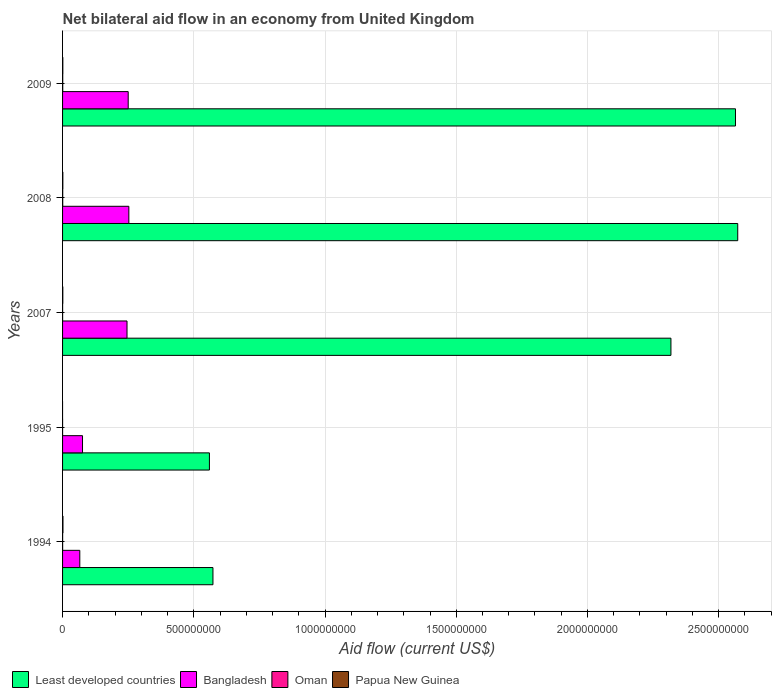How many different coloured bars are there?
Provide a short and direct response. 4. Are the number of bars per tick equal to the number of legend labels?
Provide a short and direct response. No. Are the number of bars on each tick of the Y-axis equal?
Provide a succinct answer. No. How many bars are there on the 1st tick from the top?
Your answer should be very brief. 4. How many bars are there on the 1st tick from the bottom?
Ensure brevity in your answer.  4. What is the label of the 5th group of bars from the top?
Provide a short and direct response. 1994. In how many cases, is the number of bars for a given year not equal to the number of legend labels?
Your answer should be very brief. 1. What is the net bilateral aid flow in Papua New Guinea in 1994?
Offer a very short reply. 1.51e+06. Across all years, what is the maximum net bilateral aid flow in Oman?
Keep it short and to the point. 6.40e+05. Across all years, what is the minimum net bilateral aid flow in Oman?
Your answer should be very brief. 4.00e+04. In which year was the net bilateral aid flow in Least developed countries maximum?
Your answer should be compact. 2008. What is the total net bilateral aid flow in Oman in the graph?
Keep it short and to the point. 1.62e+06. What is the difference between the net bilateral aid flow in Least developed countries in 2007 and that in 2009?
Ensure brevity in your answer.  -2.46e+08. What is the difference between the net bilateral aid flow in Bangladesh in 2009 and the net bilateral aid flow in Least developed countries in 2007?
Make the answer very short. -2.07e+09. What is the average net bilateral aid flow in Bangladesh per year?
Offer a very short reply. 1.78e+08. In the year 1995, what is the difference between the net bilateral aid flow in Oman and net bilateral aid flow in Bangladesh?
Give a very brief answer. -7.60e+07. What is the ratio of the net bilateral aid flow in Bangladesh in 1995 to that in 2007?
Ensure brevity in your answer.  0.31. Is it the case that in every year, the sum of the net bilateral aid flow in Papua New Guinea and net bilateral aid flow in Oman is greater than the sum of net bilateral aid flow in Least developed countries and net bilateral aid flow in Bangladesh?
Keep it short and to the point. No. Is it the case that in every year, the sum of the net bilateral aid flow in Oman and net bilateral aid flow in Bangladesh is greater than the net bilateral aid flow in Least developed countries?
Your answer should be very brief. No. How many bars are there?
Offer a very short reply. 19. Are all the bars in the graph horizontal?
Ensure brevity in your answer.  Yes. How many years are there in the graph?
Your response must be concise. 5. What is the difference between two consecutive major ticks on the X-axis?
Make the answer very short. 5.00e+08. Are the values on the major ticks of X-axis written in scientific E-notation?
Make the answer very short. No. Does the graph contain any zero values?
Make the answer very short. Yes. Does the graph contain grids?
Provide a succinct answer. Yes. Where does the legend appear in the graph?
Give a very brief answer. Bottom left. What is the title of the graph?
Your answer should be compact. Net bilateral aid flow in an economy from United Kingdom. Does "Suriname" appear as one of the legend labels in the graph?
Give a very brief answer. No. What is the Aid flow (current US$) of Least developed countries in 1994?
Your answer should be very brief. 5.73e+08. What is the Aid flow (current US$) in Bangladesh in 1994?
Provide a succinct answer. 6.57e+07. What is the Aid flow (current US$) in Oman in 1994?
Ensure brevity in your answer.  2.10e+05. What is the Aid flow (current US$) of Papua New Guinea in 1994?
Your answer should be compact. 1.51e+06. What is the Aid flow (current US$) of Least developed countries in 1995?
Keep it short and to the point. 5.60e+08. What is the Aid flow (current US$) of Bangladesh in 1995?
Make the answer very short. 7.60e+07. What is the Aid flow (current US$) in Oman in 1995?
Give a very brief answer. 4.00e+04. What is the Aid flow (current US$) in Papua New Guinea in 1995?
Offer a very short reply. 0. What is the Aid flow (current US$) of Least developed countries in 2007?
Your answer should be very brief. 2.32e+09. What is the Aid flow (current US$) in Bangladesh in 2007?
Your answer should be compact. 2.46e+08. What is the Aid flow (current US$) in Papua New Guinea in 2007?
Your answer should be very brief. 9.60e+05. What is the Aid flow (current US$) in Least developed countries in 2008?
Provide a short and direct response. 2.57e+09. What is the Aid flow (current US$) of Bangladesh in 2008?
Make the answer very short. 2.53e+08. What is the Aid flow (current US$) of Oman in 2008?
Your answer should be compact. 5.60e+05. What is the Aid flow (current US$) of Papua New Guinea in 2008?
Offer a very short reply. 1.07e+06. What is the Aid flow (current US$) of Least developed countries in 2009?
Keep it short and to the point. 2.56e+09. What is the Aid flow (current US$) in Bangladesh in 2009?
Ensure brevity in your answer.  2.50e+08. What is the Aid flow (current US$) in Oman in 2009?
Your response must be concise. 6.40e+05. What is the Aid flow (current US$) in Papua New Guinea in 2009?
Your response must be concise. 9.80e+05. Across all years, what is the maximum Aid flow (current US$) of Least developed countries?
Provide a short and direct response. 2.57e+09. Across all years, what is the maximum Aid flow (current US$) of Bangladesh?
Give a very brief answer. 2.53e+08. Across all years, what is the maximum Aid flow (current US$) of Oman?
Provide a succinct answer. 6.40e+05. Across all years, what is the maximum Aid flow (current US$) in Papua New Guinea?
Your answer should be very brief. 1.51e+06. Across all years, what is the minimum Aid flow (current US$) of Least developed countries?
Provide a succinct answer. 5.60e+08. Across all years, what is the minimum Aid flow (current US$) in Bangladesh?
Keep it short and to the point. 6.57e+07. Across all years, what is the minimum Aid flow (current US$) in Oman?
Your response must be concise. 4.00e+04. What is the total Aid flow (current US$) of Least developed countries in the graph?
Your response must be concise. 8.59e+09. What is the total Aid flow (current US$) in Bangladesh in the graph?
Provide a short and direct response. 8.90e+08. What is the total Aid flow (current US$) of Oman in the graph?
Make the answer very short. 1.62e+06. What is the total Aid flow (current US$) of Papua New Guinea in the graph?
Give a very brief answer. 4.52e+06. What is the difference between the Aid flow (current US$) in Least developed countries in 1994 and that in 1995?
Your answer should be very brief. 1.34e+07. What is the difference between the Aid flow (current US$) of Bangladesh in 1994 and that in 1995?
Provide a succinct answer. -1.03e+07. What is the difference between the Aid flow (current US$) in Oman in 1994 and that in 1995?
Ensure brevity in your answer.  1.70e+05. What is the difference between the Aid flow (current US$) in Least developed countries in 1994 and that in 2007?
Your answer should be very brief. -1.75e+09. What is the difference between the Aid flow (current US$) of Bangladesh in 1994 and that in 2007?
Make the answer very short. -1.80e+08. What is the difference between the Aid flow (current US$) of Papua New Guinea in 1994 and that in 2007?
Give a very brief answer. 5.50e+05. What is the difference between the Aid flow (current US$) in Least developed countries in 1994 and that in 2008?
Keep it short and to the point. -2.00e+09. What is the difference between the Aid flow (current US$) in Bangladesh in 1994 and that in 2008?
Give a very brief answer. -1.87e+08. What is the difference between the Aid flow (current US$) in Oman in 1994 and that in 2008?
Your answer should be compact. -3.50e+05. What is the difference between the Aid flow (current US$) of Least developed countries in 1994 and that in 2009?
Make the answer very short. -1.99e+09. What is the difference between the Aid flow (current US$) of Bangladesh in 1994 and that in 2009?
Provide a short and direct response. -1.84e+08. What is the difference between the Aid flow (current US$) of Oman in 1994 and that in 2009?
Make the answer very short. -4.30e+05. What is the difference between the Aid flow (current US$) of Papua New Guinea in 1994 and that in 2009?
Make the answer very short. 5.30e+05. What is the difference between the Aid flow (current US$) of Least developed countries in 1995 and that in 2007?
Provide a short and direct response. -1.76e+09. What is the difference between the Aid flow (current US$) of Bangladesh in 1995 and that in 2007?
Your answer should be compact. -1.70e+08. What is the difference between the Aid flow (current US$) in Oman in 1995 and that in 2007?
Give a very brief answer. -1.30e+05. What is the difference between the Aid flow (current US$) of Least developed countries in 1995 and that in 2008?
Your answer should be very brief. -2.01e+09. What is the difference between the Aid flow (current US$) in Bangladesh in 1995 and that in 2008?
Your answer should be compact. -1.77e+08. What is the difference between the Aid flow (current US$) of Oman in 1995 and that in 2008?
Provide a short and direct response. -5.20e+05. What is the difference between the Aid flow (current US$) of Least developed countries in 1995 and that in 2009?
Your answer should be very brief. -2.00e+09. What is the difference between the Aid flow (current US$) of Bangladesh in 1995 and that in 2009?
Offer a terse response. -1.74e+08. What is the difference between the Aid flow (current US$) of Oman in 1995 and that in 2009?
Make the answer very short. -6.00e+05. What is the difference between the Aid flow (current US$) of Least developed countries in 2007 and that in 2008?
Keep it short and to the point. -2.55e+08. What is the difference between the Aid flow (current US$) in Bangladesh in 2007 and that in 2008?
Your answer should be compact. -6.96e+06. What is the difference between the Aid flow (current US$) of Oman in 2007 and that in 2008?
Provide a succinct answer. -3.90e+05. What is the difference between the Aid flow (current US$) of Papua New Guinea in 2007 and that in 2008?
Offer a terse response. -1.10e+05. What is the difference between the Aid flow (current US$) of Least developed countries in 2007 and that in 2009?
Provide a succinct answer. -2.46e+08. What is the difference between the Aid flow (current US$) of Bangladesh in 2007 and that in 2009?
Ensure brevity in your answer.  -4.51e+06. What is the difference between the Aid flow (current US$) in Oman in 2007 and that in 2009?
Make the answer very short. -4.70e+05. What is the difference between the Aid flow (current US$) in Papua New Guinea in 2007 and that in 2009?
Give a very brief answer. -2.00e+04. What is the difference between the Aid flow (current US$) of Least developed countries in 2008 and that in 2009?
Your answer should be compact. 8.55e+06. What is the difference between the Aid flow (current US$) of Bangladesh in 2008 and that in 2009?
Provide a succinct answer. 2.45e+06. What is the difference between the Aid flow (current US$) in Oman in 2008 and that in 2009?
Give a very brief answer. -8.00e+04. What is the difference between the Aid flow (current US$) in Papua New Guinea in 2008 and that in 2009?
Provide a succinct answer. 9.00e+04. What is the difference between the Aid flow (current US$) of Least developed countries in 1994 and the Aid flow (current US$) of Bangladesh in 1995?
Your response must be concise. 4.97e+08. What is the difference between the Aid flow (current US$) of Least developed countries in 1994 and the Aid flow (current US$) of Oman in 1995?
Make the answer very short. 5.73e+08. What is the difference between the Aid flow (current US$) of Bangladesh in 1994 and the Aid flow (current US$) of Oman in 1995?
Your answer should be very brief. 6.56e+07. What is the difference between the Aid flow (current US$) in Least developed countries in 1994 and the Aid flow (current US$) in Bangladesh in 2007?
Keep it short and to the point. 3.27e+08. What is the difference between the Aid flow (current US$) of Least developed countries in 1994 and the Aid flow (current US$) of Oman in 2007?
Your answer should be compact. 5.73e+08. What is the difference between the Aid flow (current US$) in Least developed countries in 1994 and the Aid flow (current US$) in Papua New Guinea in 2007?
Keep it short and to the point. 5.72e+08. What is the difference between the Aid flow (current US$) of Bangladesh in 1994 and the Aid flow (current US$) of Oman in 2007?
Your response must be concise. 6.55e+07. What is the difference between the Aid flow (current US$) of Bangladesh in 1994 and the Aid flow (current US$) of Papua New Guinea in 2007?
Ensure brevity in your answer.  6.47e+07. What is the difference between the Aid flow (current US$) of Oman in 1994 and the Aid flow (current US$) of Papua New Guinea in 2007?
Offer a terse response. -7.50e+05. What is the difference between the Aid flow (current US$) in Least developed countries in 1994 and the Aid flow (current US$) in Bangladesh in 2008?
Your answer should be compact. 3.20e+08. What is the difference between the Aid flow (current US$) of Least developed countries in 1994 and the Aid flow (current US$) of Oman in 2008?
Your answer should be compact. 5.72e+08. What is the difference between the Aid flow (current US$) in Least developed countries in 1994 and the Aid flow (current US$) in Papua New Guinea in 2008?
Your response must be concise. 5.72e+08. What is the difference between the Aid flow (current US$) of Bangladesh in 1994 and the Aid flow (current US$) of Oman in 2008?
Make the answer very short. 6.51e+07. What is the difference between the Aid flow (current US$) in Bangladesh in 1994 and the Aid flow (current US$) in Papua New Guinea in 2008?
Make the answer very short. 6.46e+07. What is the difference between the Aid flow (current US$) in Oman in 1994 and the Aid flow (current US$) in Papua New Guinea in 2008?
Provide a short and direct response. -8.60e+05. What is the difference between the Aid flow (current US$) in Least developed countries in 1994 and the Aid flow (current US$) in Bangladesh in 2009?
Your answer should be very brief. 3.23e+08. What is the difference between the Aid flow (current US$) of Least developed countries in 1994 and the Aid flow (current US$) of Oman in 2009?
Offer a very short reply. 5.72e+08. What is the difference between the Aid flow (current US$) in Least developed countries in 1994 and the Aid flow (current US$) in Papua New Guinea in 2009?
Your answer should be compact. 5.72e+08. What is the difference between the Aid flow (current US$) of Bangladesh in 1994 and the Aid flow (current US$) of Oman in 2009?
Offer a very short reply. 6.50e+07. What is the difference between the Aid flow (current US$) in Bangladesh in 1994 and the Aid flow (current US$) in Papua New Guinea in 2009?
Offer a very short reply. 6.47e+07. What is the difference between the Aid flow (current US$) in Oman in 1994 and the Aid flow (current US$) in Papua New Guinea in 2009?
Offer a terse response. -7.70e+05. What is the difference between the Aid flow (current US$) in Least developed countries in 1995 and the Aid flow (current US$) in Bangladesh in 2007?
Provide a succinct answer. 3.14e+08. What is the difference between the Aid flow (current US$) in Least developed countries in 1995 and the Aid flow (current US$) in Oman in 2007?
Your answer should be very brief. 5.59e+08. What is the difference between the Aid flow (current US$) of Least developed countries in 1995 and the Aid flow (current US$) of Papua New Guinea in 2007?
Offer a very short reply. 5.59e+08. What is the difference between the Aid flow (current US$) of Bangladesh in 1995 and the Aid flow (current US$) of Oman in 2007?
Provide a succinct answer. 7.58e+07. What is the difference between the Aid flow (current US$) in Bangladesh in 1995 and the Aid flow (current US$) in Papua New Guinea in 2007?
Your answer should be compact. 7.50e+07. What is the difference between the Aid flow (current US$) of Oman in 1995 and the Aid flow (current US$) of Papua New Guinea in 2007?
Ensure brevity in your answer.  -9.20e+05. What is the difference between the Aid flow (current US$) of Least developed countries in 1995 and the Aid flow (current US$) of Bangladesh in 2008?
Keep it short and to the point. 3.07e+08. What is the difference between the Aid flow (current US$) of Least developed countries in 1995 and the Aid flow (current US$) of Oman in 2008?
Ensure brevity in your answer.  5.59e+08. What is the difference between the Aid flow (current US$) in Least developed countries in 1995 and the Aid flow (current US$) in Papua New Guinea in 2008?
Provide a succinct answer. 5.59e+08. What is the difference between the Aid flow (current US$) in Bangladesh in 1995 and the Aid flow (current US$) in Oman in 2008?
Offer a very short reply. 7.54e+07. What is the difference between the Aid flow (current US$) of Bangladesh in 1995 and the Aid flow (current US$) of Papua New Guinea in 2008?
Offer a very short reply. 7.49e+07. What is the difference between the Aid flow (current US$) of Oman in 1995 and the Aid flow (current US$) of Papua New Guinea in 2008?
Offer a terse response. -1.03e+06. What is the difference between the Aid flow (current US$) in Least developed countries in 1995 and the Aid flow (current US$) in Bangladesh in 2009?
Keep it short and to the point. 3.10e+08. What is the difference between the Aid flow (current US$) in Least developed countries in 1995 and the Aid flow (current US$) in Oman in 2009?
Your answer should be compact. 5.59e+08. What is the difference between the Aid flow (current US$) in Least developed countries in 1995 and the Aid flow (current US$) in Papua New Guinea in 2009?
Give a very brief answer. 5.59e+08. What is the difference between the Aid flow (current US$) of Bangladesh in 1995 and the Aid flow (current US$) of Oman in 2009?
Ensure brevity in your answer.  7.54e+07. What is the difference between the Aid flow (current US$) in Bangladesh in 1995 and the Aid flow (current US$) in Papua New Guinea in 2009?
Ensure brevity in your answer.  7.50e+07. What is the difference between the Aid flow (current US$) in Oman in 1995 and the Aid flow (current US$) in Papua New Guinea in 2009?
Make the answer very short. -9.40e+05. What is the difference between the Aid flow (current US$) of Least developed countries in 2007 and the Aid flow (current US$) of Bangladesh in 2008?
Offer a very short reply. 2.07e+09. What is the difference between the Aid flow (current US$) in Least developed countries in 2007 and the Aid flow (current US$) in Oman in 2008?
Provide a succinct answer. 2.32e+09. What is the difference between the Aid flow (current US$) of Least developed countries in 2007 and the Aid flow (current US$) of Papua New Guinea in 2008?
Offer a terse response. 2.32e+09. What is the difference between the Aid flow (current US$) in Bangladesh in 2007 and the Aid flow (current US$) in Oman in 2008?
Make the answer very short. 2.45e+08. What is the difference between the Aid flow (current US$) in Bangladesh in 2007 and the Aid flow (current US$) in Papua New Guinea in 2008?
Your answer should be very brief. 2.44e+08. What is the difference between the Aid flow (current US$) in Oman in 2007 and the Aid flow (current US$) in Papua New Guinea in 2008?
Your answer should be compact. -9.00e+05. What is the difference between the Aid flow (current US$) of Least developed countries in 2007 and the Aid flow (current US$) of Bangladesh in 2009?
Provide a succinct answer. 2.07e+09. What is the difference between the Aid flow (current US$) in Least developed countries in 2007 and the Aid flow (current US$) in Oman in 2009?
Offer a very short reply. 2.32e+09. What is the difference between the Aid flow (current US$) in Least developed countries in 2007 and the Aid flow (current US$) in Papua New Guinea in 2009?
Your answer should be compact. 2.32e+09. What is the difference between the Aid flow (current US$) of Bangladesh in 2007 and the Aid flow (current US$) of Oman in 2009?
Make the answer very short. 2.45e+08. What is the difference between the Aid flow (current US$) of Bangladesh in 2007 and the Aid flow (current US$) of Papua New Guinea in 2009?
Provide a succinct answer. 2.45e+08. What is the difference between the Aid flow (current US$) in Oman in 2007 and the Aid flow (current US$) in Papua New Guinea in 2009?
Offer a very short reply. -8.10e+05. What is the difference between the Aid flow (current US$) of Least developed countries in 2008 and the Aid flow (current US$) of Bangladesh in 2009?
Make the answer very short. 2.32e+09. What is the difference between the Aid flow (current US$) in Least developed countries in 2008 and the Aid flow (current US$) in Oman in 2009?
Your answer should be compact. 2.57e+09. What is the difference between the Aid flow (current US$) of Least developed countries in 2008 and the Aid flow (current US$) of Papua New Guinea in 2009?
Your answer should be very brief. 2.57e+09. What is the difference between the Aid flow (current US$) in Bangladesh in 2008 and the Aid flow (current US$) in Oman in 2009?
Provide a short and direct response. 2.52e+08. What is the difference between the Aid flow (current US$) of Bangladesh in 2008 and the Aid flow (current US$) of Papua New Guinea in 2009?
Keep it short and to the point. 2.52e+08. What is the difference between the Aid flow (current US$) in Oman in 2008 and the Aid flow (current US$) in Papua New Guinea in 2009?
Your response must be concise. -4.20e+05. What is the average Aid flow (current US$) of Least developed countries per year?
Your answer should be very brief. 1.72e+09. What is the average Aid flow (current US$) of Bangladesh per year?
Offer a very short reply. 1.78e+08. What is the average Aid flow (current US$) in Oman per year?
Your answer should be compact. 3.24e+05. What is the average Aid flow (current US$) in Papua New Guinea per year?
Provide a short and direct response. 9.04e+05. In the year 1994, what is the difference between the Aid flow (current US$) of Least developed countries and Aid flow (current US$) of Bangladesh?
Your answer should be very brief. 5.07e+08. In the year 1994, what is the difference between the Aid flow (current US$) in Least developed countries and Aid flow (current US$) in Oman?
Provide a short and direct response. 5.73e+08. In the year 1994, what is the difference between the Aid flow (current US$) in Least developed countries and Aid flow (current US$) in Papua New Guinea?
Offer a very short reply. 5.71e+08. In the year 1994, what is the difference between the Aid flow (current US$) in Bangladesh and Aid flow (current US$) in Oman?
Make the answer very short. 6.55e+07. In the year 1994, what is the difference between the Aid flow (current US$) in Bangladesh and Aid flow (current US$) in Papua New Guinea?
Your answer should be very brief. 6.42e+07. In the year 1994, what is the difference between the Aid flow (current US$) in Oman and Aid flow (current US$) in Papua New Guinea?
Provide a short and direct response. -1.30e+06. In the year 1995, what is the difference between the Aid flow (current US$) of Least developed countries and Aid flow (current US$) of Bangladesh?
Offer a terse response. 4.84e+08. In the year 1995, what is the difference between the Aid flow (current US$) in Least developed countries and Aid flow (current US$) in Oman?
Your answer should be very brief. 5.60e+08. In the year 1995, what is the difference between the Aid flow (current US$) of Bangladesh and Aid flow (current US$) of Oman?
Offer a very short reply. 7.60e+07. In the year 2007, what is the difference between the Aid flow (current US$) in Least developed countries and Aid flow (current US$) in Bangladesh?
Give a very brief answer. 2.07e+09. In the year 2007, what is the difference between the Aid flow (current US$) of Least developed countries and Aid flow (current US$) of Oman?
Your answer should be very brief. 2.32e+09. In the year 2007, what is the difference between the Aid flow (current US$) in Least developed countries and Aid flow (current US$) in Papua New Guinea?
Offer a terse response. 2.32e+09. In the year 2007, what is the difference between the Aid flow (current US$) in Bangladesh and Aid flow (current US$) in Oman?
Provide a succinct answer. 2.45e+08. In the year 2007, what is the difference between the Aid flow (current US$) in Bangladesh and Aid flow (current US$) in Papua New Guinea?
Give a very brief answer. 2.45e+08. In the year 2007, what is the difference between the Aid flow (current US$) in Oman and Aid flow (current US$) in Papua New Guinea?
Offer a terse response. -7.90e+05. In the year 2008, what is the difference between the Aid flow (current US$) of Least developed countries and Aid flow (current US$) of Bangladesh?
Make the answer very short. 2.32e+09. In the year 2008, what is the difference between the Aid flow (current US$) in Least developed countries and Aid flow (current US$) in Oman?
Keep it short and to the point. 2.57e+09. In the year 2008, what is the difference between the Aid flow (current US$) of Least developed countries and Aid flow (current US$) of Papua New Guinea?
Your answer should be compact. 2.57e+09. In the year 2008, what is the difference between the Aid flow (current US$) of Bangladesh and Aid flow (current US$) of Oman?
Ensure brevity in your answer.  2.52e+08. In the year 2008, what is the difference between the Aid flow (current US$) in Bangladesh and Aid flow (current US$) in Papua New Guinea?
Your response must be concise. 2.51e+08. In the year 2008, what is the difference between the Aid flow (current US$) in Oman and Aid flow (current US$) in Papua New Guinea?
Make the answer very short. -5.10e+05. In the year 2009, what is the difference between the Aid flow (current US$) of Least developed countries and Aid flow (current US$) of Bangladesh?
Your response must be concise. 2.31e+09. In the year 2009, what is the difference between the Aid flow (current US$) in Least developed countries and Aid flow (current US$) in Oman?
Keep it short and to the point. 2.56e+09. In the year 2009, what is the difference between the Aid flow (current US$) in Least developed countries and Aid flow (current US$) in Papua New Guinea?
Provide a short and direct response. 2.56e+09. In the year 2009, what is the difference between the Aid flow (current US$) in Bangladesh and Aid flow (current US$) in Oman?
Provide a succinct answer. 2.49e+08. In the year 2009, what is the difference between the Aid flow (current US$) in Bangladesh and Aid flow (current US$) in Papua New Guinea?
Your answer should be compact. 2.49e+08. What is the ratio of the Aid flow (current US$) of Least developed countries in 1994 to that in 1995?
Keep it short and to the point. 1.02. What is the ratio of the Aid flow (current US$) in Bangladesh in 1994 to that in 1995?
Your answer should be very brief. 0.86. What is the ratio of the Aid flow (current US$) of Oman in 1994 to that in 1995?
Ensure brevity in your answer.  5.25. What is the ratio of the Aid flow (current US$) of Least developed countries in 1994 to that in 2007?
Offer a very short reply. 0.25. What is the ratio of the Aid flow (current US$) of Bangladesh in 1994 to that in 2007?
Keep it short and to the point. 0.27. What is the ratio of the Aid flow (current US$) in Oman in 1994 to that in 2007?
Keep it short and to the point. 1.24. What is the ratio of the Aid flow (current US$) in Papua New Guinea in 1994 to that in 2007?
Keep it short and to the point. 1.57. What is the ratio of the Aid flow (current US$) of Least developed countries in 1994 to that in 2008?
Your response must be concise. 0.22. What is the ratio of the Aid flow (current US$) of Bangladesh in 1994 to that in 2008?
Offer a very short reply. 0.26. What is the ratio of the Aid flow (current US$) of Oman in 1994 to that in 2008?
Provide a succinct answer. 0.38. What is the ratio of the Aid flow (current US$) in Papua New Guinea in 1994 to that in 2008?
Offer a very short reply. 1.41. What is the ratio of the Aid flow (current US$) in Least developed countries in 1994 to that in 2009?
Your answer should be very brief. 0.22. What is the ratio of the Aid flow (current US$) in Bangladesh in 1994 to that in 2009?
Provide a short and direct response. 0.26. What is the ratio of the Aid flow (current US$) of Oman in 1994 to that in 2009?
Your answer should be compact. 0.33. What is the ratio of the Aid flow (current US$) in Papua New Guinea in 1994 to that in 2009?
Your answer should be very brief. 1.54. What is the ratio of the Aid flow (current US$) of Least developed countries in 1995 to that in 2007?
Offer a terse response. 0.24. What is the ratio of the Aid flow (current US$) of Bangladesh in 1995 to that in 2007?
Provide a succinct answer. 0.31. What is the ratio of the Aid flow (current US$) in Oman in 1995 to that in 2007?
Make the answer very short. 0.24. What is the ratio of the Aid flow (current US$) of Least developed countries in 1995 to that in 2008?
Offer a terse response. 0.22. What is the ratio of the Aid flow (current US$) of Bangladesh in 1995 to that in 2008?
Offer a very short reply. 0.3. What is the ratio of the Aid flow (current US$) of Oman in 1995 to that in 2008?
Your response must be concise. 0.07. What is the ratio of the Aid flow (current US$) of Least developed countries in 1995 to that in 2009?
Offer a terse response. 0.22. What is the ratio of the Aid flow (current US$) in Bangladesh in 1995 to that in 2009?
Your response must be concise. 0.3. What is the ratio of the Aid flow (current US$) in Oman in 1995 to that in 2009?
Give a very brief answer. 0.06. What is the ratio of the Aid flow (current US$) of Least developed countries in 2007 to that in 2008?
Give a very brief answer. 0.9. What is the ratio of the Aid flow (current US$) in Bangladesh in 2007 to that in 2008?
Make the answer very short. 0.97. What is the ratio of the Aid flow (current US$) of Oman in 2007 to that in 2008?
Provide a succinct answer. 0.3. What is the ratio of the Aid flow (current US$) in Papua New Guinea in 2007 to that in 2008?
Your answer should be compact. 0.9. What is the ratio of the Aid flow (current US$) of Least developed countries in 2007 to that in 2009?
Provide a succinct answer. 0.9. What is the ratio of the Aid flow (current US$) of Bangladesh in 2007 to that in 2009?
Make the answer very short. 0.98. What is the ratio of the Aid flow (current US$) in Oman in 2007 to that in 2009?
Offer a terse response. 0.27. What is the ratio of the Aid flow (current US$) in Papua New Guinea in 2007 to that in 2009?
Provide a short and direct response. 0.98. What is the ratio of the Aid flow (current US$) in Least developed countries in 2008 to that in 2009?
Provide a succinct answer. 1. What is the ratio of the Aid flow (current US$) of Bangladesh in 2008 to that in 2009?
Provide a succinct answer. 1.01. What is the ratio of the Aid flow (current US$) in Oman in 2008 to that in 2009?
Your response must be concise. 0.88. What is the ratio of the Aid flow (current US$) in Papua New Guinea in 2008 to that in 2009?
Give a very brief answer. 1.09. What is the difference between the highest and the second highest Aid flow (current US$) of Least developed countries?
Keep it short and to the point. 8.55e+06. What is the difference between the highest and the second highest Aid flow (current US$) in Bangladesh?
Keep it short and to the point. 2.45e+06. What is the difference between the highest and the second highest Aid flow (current US$) of Papua New Guinea?
Your answer should be compact. 4.40e+05. What is the difference between the highest and the lowest Aid flow (current US$) in Least developed countries?
Ensure brevity in your answer.  2.01e+09. What is the difference between the highest and the lowest Aid flow (current US$) in Bangladesh?
Provide a short and direct response. 1.87e+08. What is the difference between the highest and the lowest Aid flow (current US$) in Papua New Guinea?
Ensure brevity in your answer.  1.51e+06. 